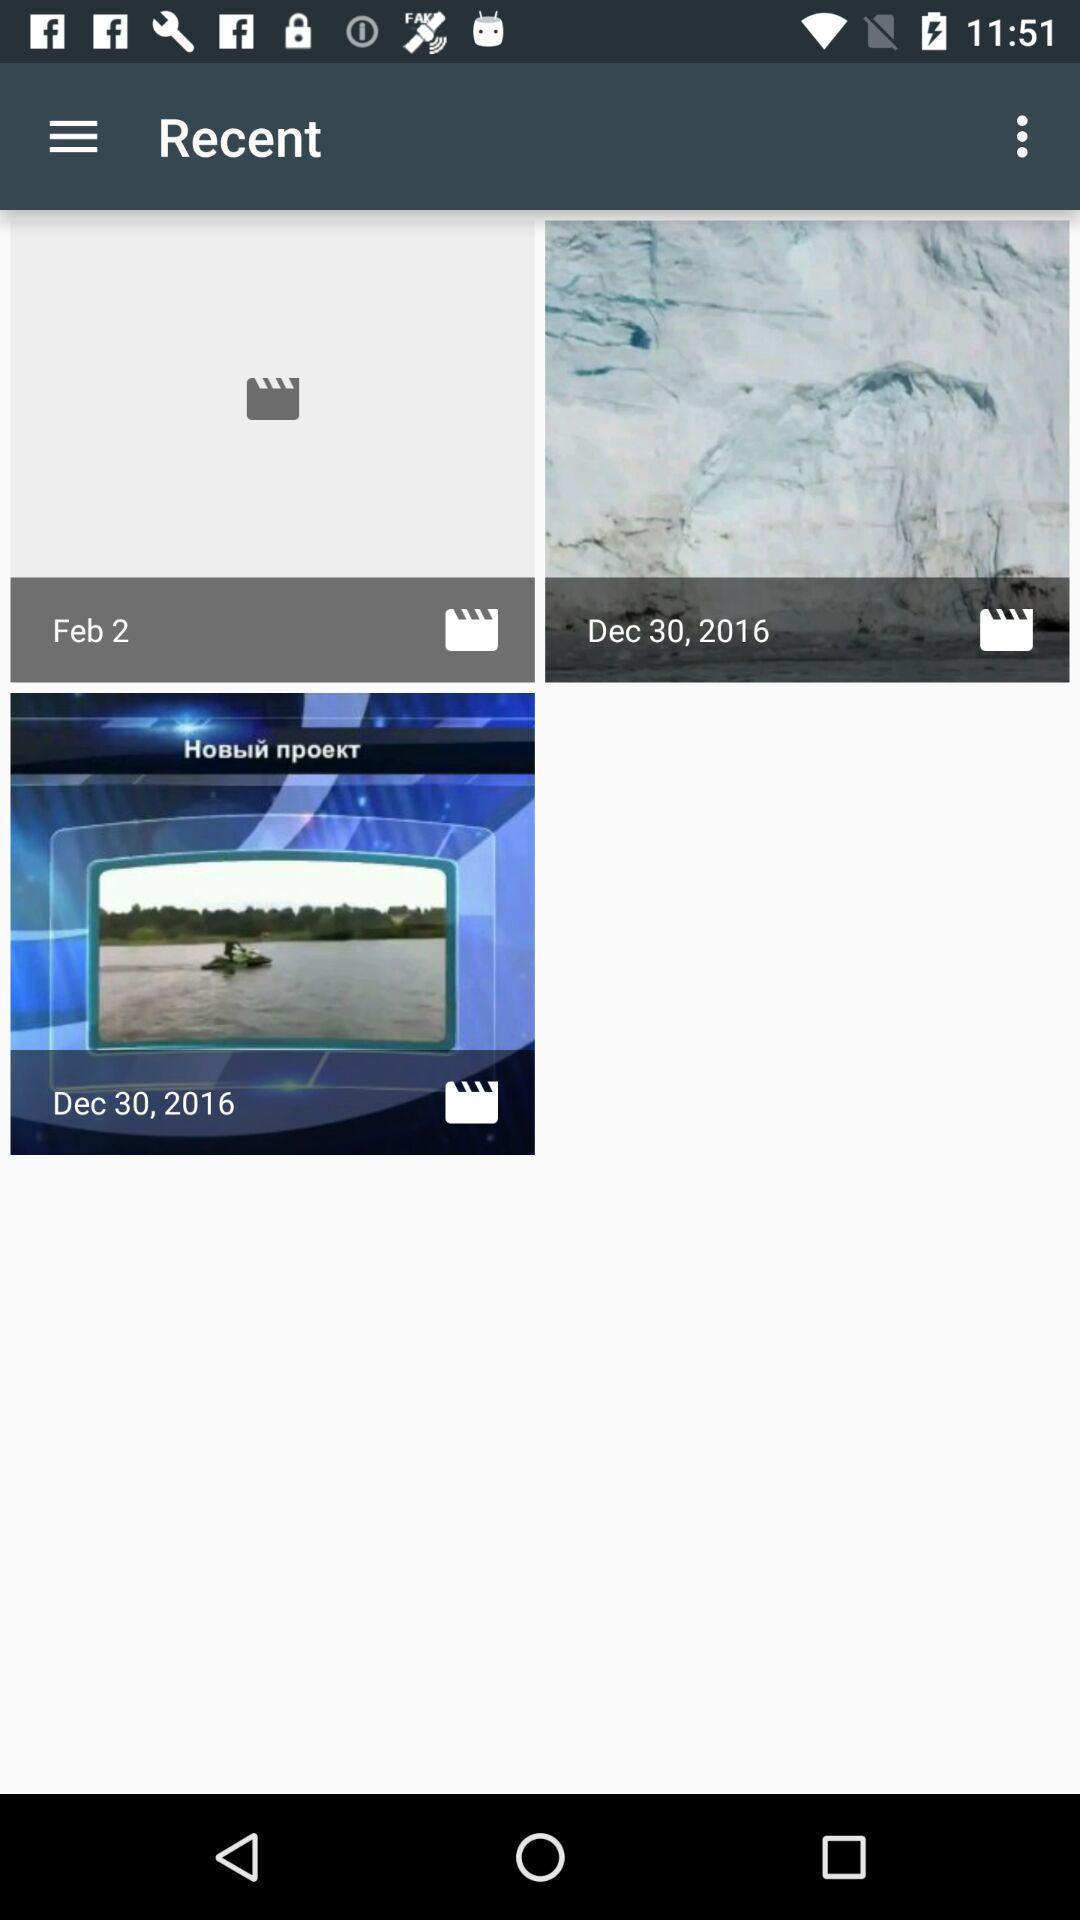Describe the key features of this screenshot. Screen showing images. 